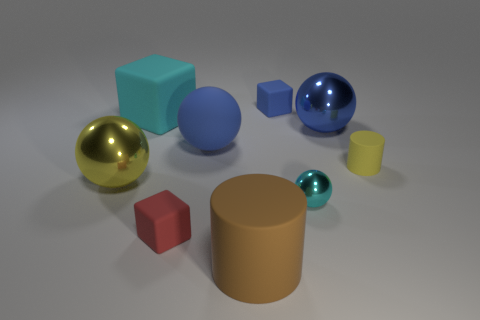What is the color of the sphere that is in front of the yellow thing on the left side of the tiny matte cylinder?
Ensure brevity in your answer.  Cyan. Is the brown thing made of the same material as the cyan object that is on the right side of the red matte block?
Your answer should be compact. No. What color is the cylinder that is in front of the big metal sphere on the left side of the shiny sphere behind the small yellow thing?
Your answer should be compact. Brown. Is there any other thing that has the same shape as the big brown object?
Offer a very short reply. Yes. Are there more small metallic things than big purple metallic cubes?
Make the answer very short. Yes. How many rubber objects are on the left side of the small blue object and to the right of the tiny blue matte block?
Your answer should be very brief. 0. How many big cyan things are to the left of the cylinder behind the big brown cylinder?
Give a very brief answer. 1. Do the cyan thing on the right side of the large cube and the block that is in front of the small shiny object have the same size?
Make the answer very short. Yes. How many cyan objects are there?
Your answer should be very brief. 2. How many big blue spheres have the same material as the large block?
Give a very brief answer. 1. 